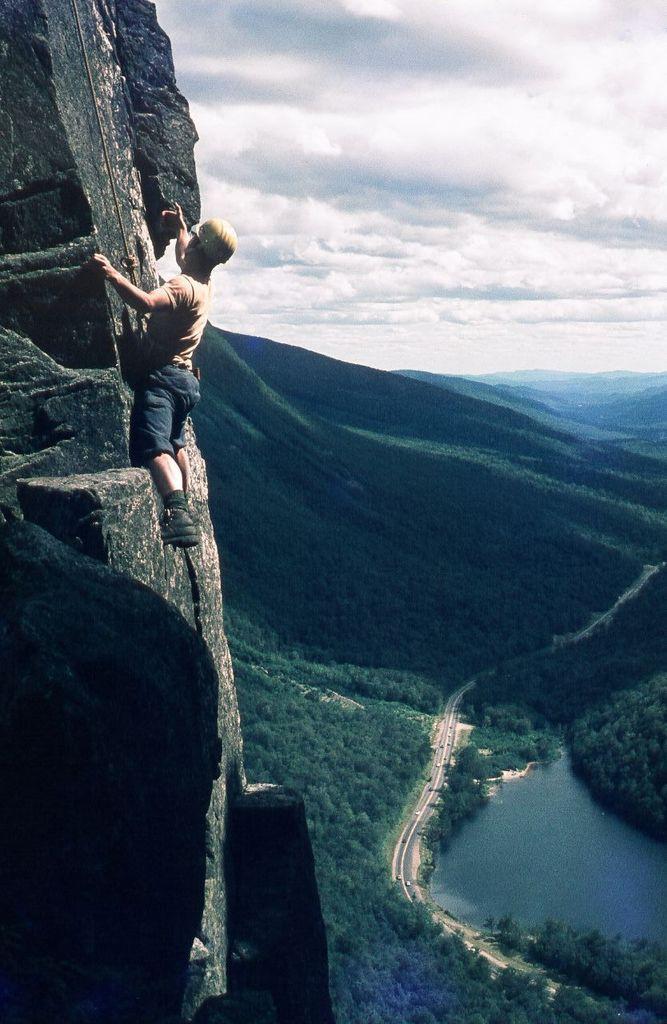Describe this image in one or two sentences. A person is climbing a mountain at the left. There are hills, trees, roads and vehicles on it and there is water. 